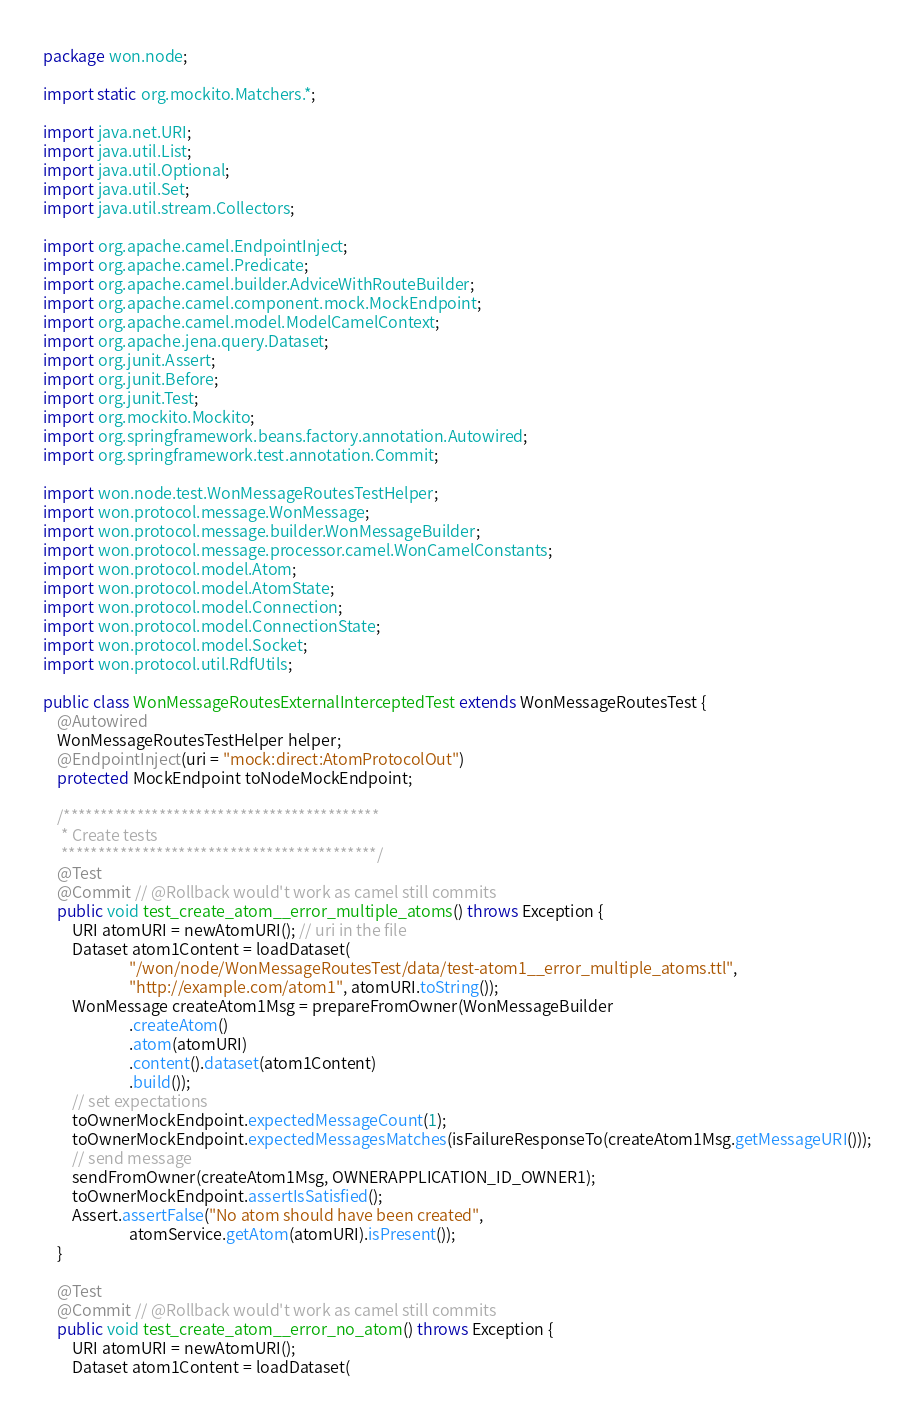<code> <loc_0><loc_0><loc_500><loc_500><_Java_>package won.node;

import static org.mockito.Matchers.*;

import java.net.URI;
import java.util.List;
import java.util.Optional;
import java.util.Set;
import java.util.stream.Collectors;

import org.apache.camel.EndpointInject;
import org.apache.camel.Predicate;
import org.apache.camel.builder.AdviceWithRouteBuilder;
import org.apache.camel.component.mock.MockEndpoint;
import org.apache.camel.model.ModelCamelContext;
import org.apache.jena.query.Dataset;
import org.junit.Assert;
import org.junit.Before;
import org.junit.Test;
import org.mockito.Mockito;
import org.springframework.beans.factory.annotation.Autowired;
import org.springframework.test.annotation.Commit;

import won.node.test.WonMessageRoutesTestHelper;
import won.protocol.message.WonMessage;
import won.protocol.message.builder.WonMessageBuilder;
import won.protocol.message.processor.camel.WonCamelConstants;
import won.protocol.model.Atom;
import won.protocol.model.AtomState;
import won.protocol.model.Connection;
import won.protocol.model.ConnectionState;
import won.protocol.model.Socket;
import won.protocol.util.RdfUtils;

public class WonMessageRoutesExternalInterceptedTest extends WonMessageRoutesTest {
    @Autowired
    WonMessageRoutesTestHelper helper;
    @EndpointInject(uri = "mock:direct:AtomProtocolOut")
    protected MockEndpoint toNodeMockEndpoint;

    /*******************************************
     * Create tests
     *******************************************/
    @Test
    @Commit // @Rollback would't work as camel still commits
    public void test_create_atom__error_multiple_atoms() throws Exception {
        URI atomURI = newAtomURI(); // uri in the file
        Dataset atom1Content = loadDataset(
                        "/won/node/WonMessageRoutesTest/data/test-atom1__error_multiple_atoms.ttl",
                        "http://example.com/atom1", atomURI.toString());
        WonMessage createAtom1Msg = prepareFromOwner(WonMessageBuilder
                        .createAtom()
                        .atom(atomURI)
                        .content().dataset(atom1Content)
                        .build());
        // set expectations
        toOwnerMockEndpoint.expectedMessageCount(1);
        toOwnerMockEndpoint.expectedMessagesMatches(isFailureResponseTo(createAtom1Msg.getMessageURI()));
        // send message
        sendFromOwner(createAtom1Msg, OWNERAPPLICATION_ID_OWNER1);
        toOwnerMockEndpoint.assertIsSatisfied();
        Assert.assertFalse("No atom should have been created",
                        atomService.getAtom(atomURI).isPresent());
    }

    @Test
    @Commit // @Rollback would't work as camel still commits
    public void test_create_atom__error_no_atom() throws Exception {
        URI atomURI = newAtomURI();
        Dataset atom1Content = loadDataset(</code> 